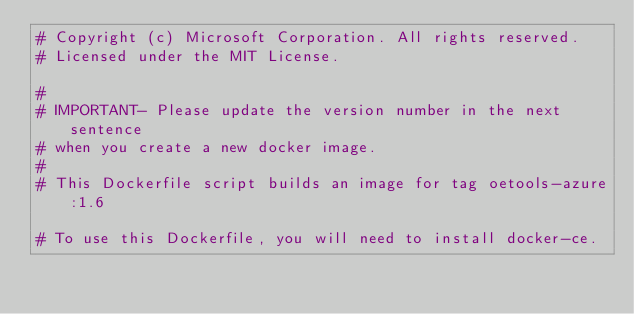<code> <loc_0><loc_0><loc_500><loc_500><_Dockerfile_># Copyright (c) Microsoft Corporation. All rights reserved.
# Licensed under the MIT License.

#
# IMPORTANT- Please update the version number in the next sentence
# when you create a new docker image.
#
# This Dockerfile script builds an image for tag oetools-azure:1.6

# To use this Dockerfile, you will need to install docker-ce.</code> 